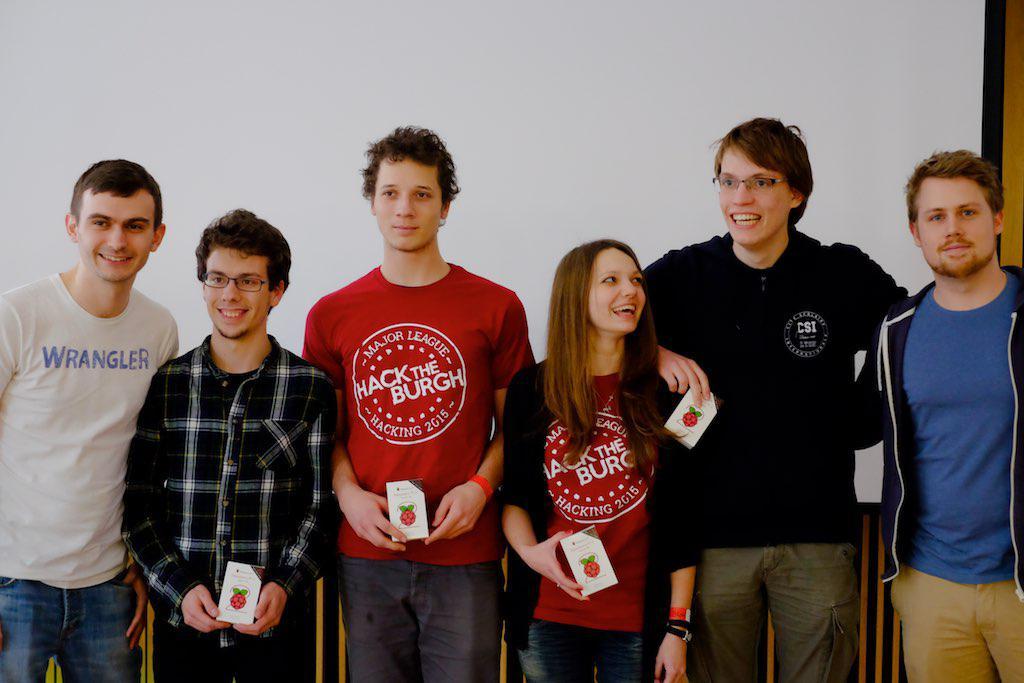What clothing brand does the boy on the far left appreciate?
Provide a succinct answer. Wrangler. What are the three words in large white capitals on the red t-shirt?
Your response must be concise. Hack the burgh. 